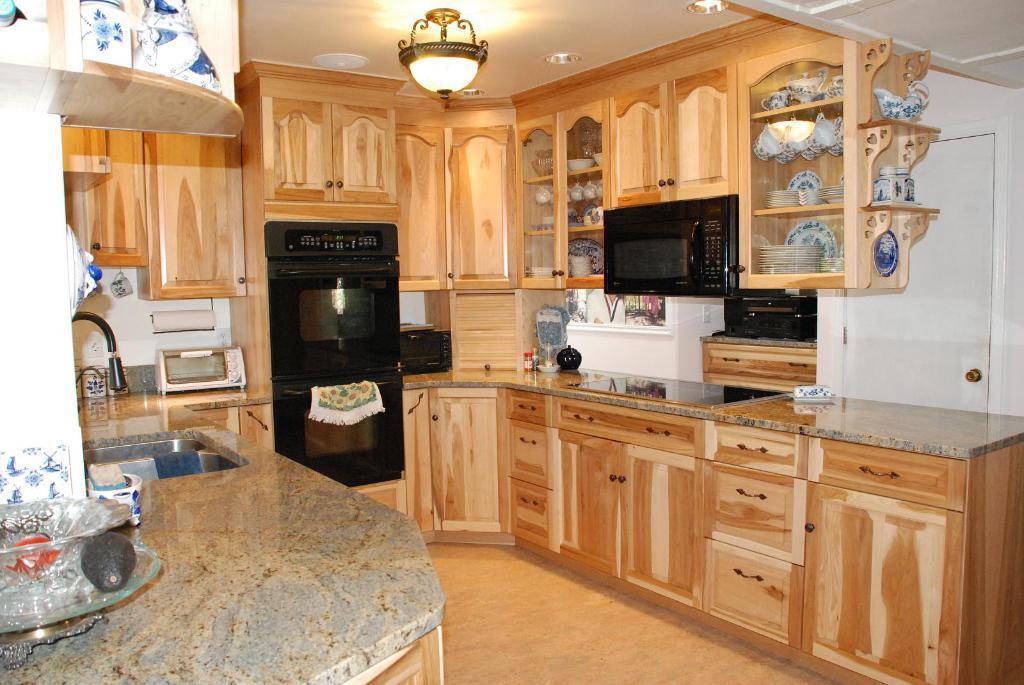How would you summarize this image in a sentence or two? This is a picture of inside of the house on the right side there is one oven, in a cupboard and also in the cupboard there are some plates and pots. In the center there is one television, on the television there is one cloth and beside the television there is one oven and on the left side there is a wash basin and some objects, glass plate, stone, and a bowl. At the bottom there is floor and at the top of the image there is ceiling and some lights. 